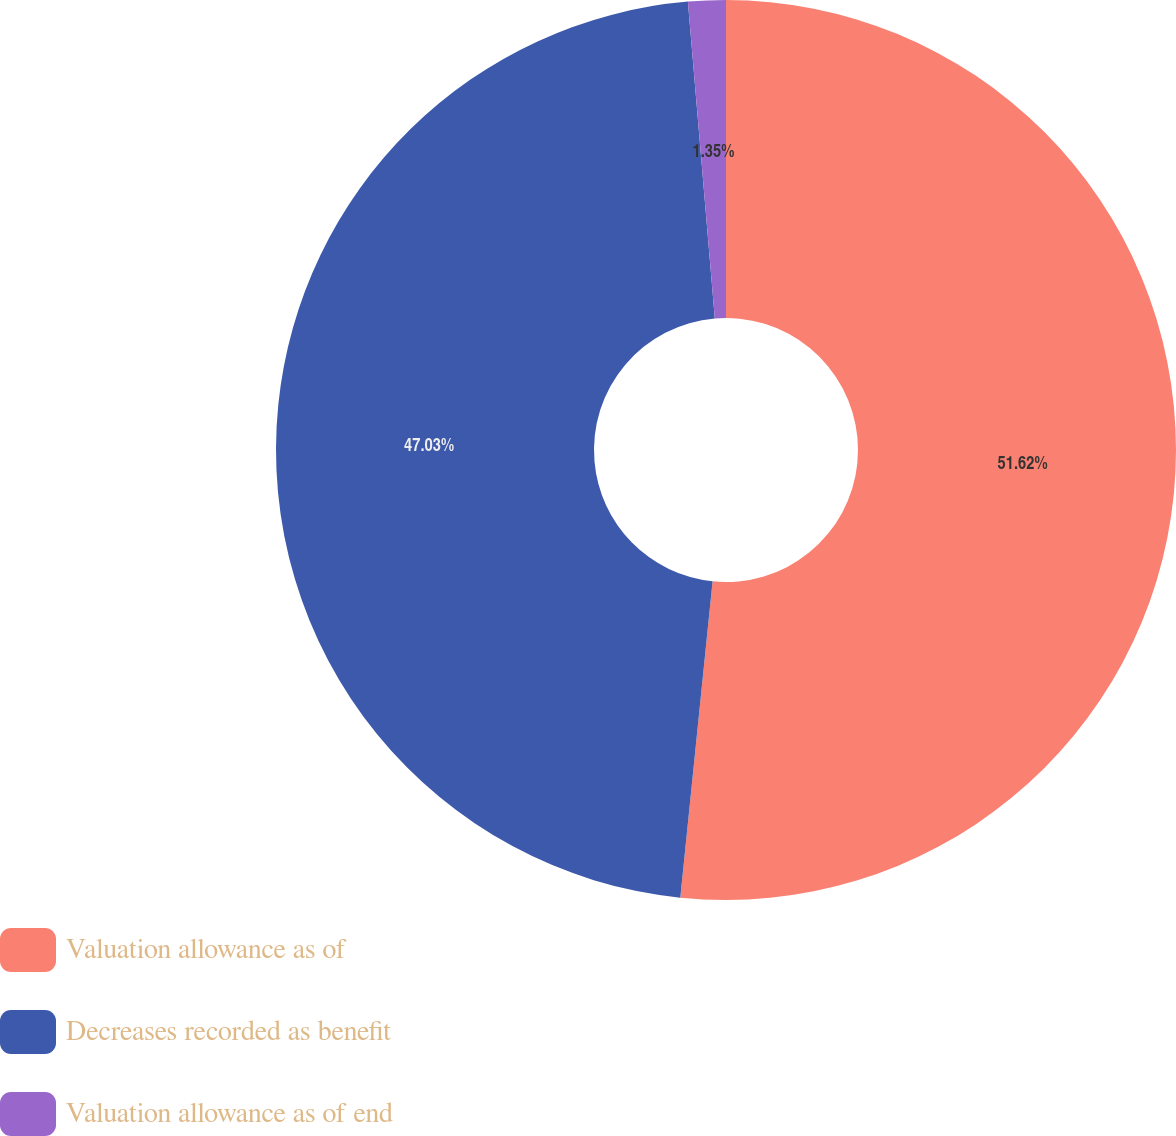<chart> <loc_0><loc_0><loc_500><loc_500><pie_chart><fcel>Valuation allowance as of<fcel>Decreases recorded as benefit<fcel>Valuation allowance as of end<nl><fcel>51.62%<fcel>47.03%<fcel>1.35%<nl></chart> 